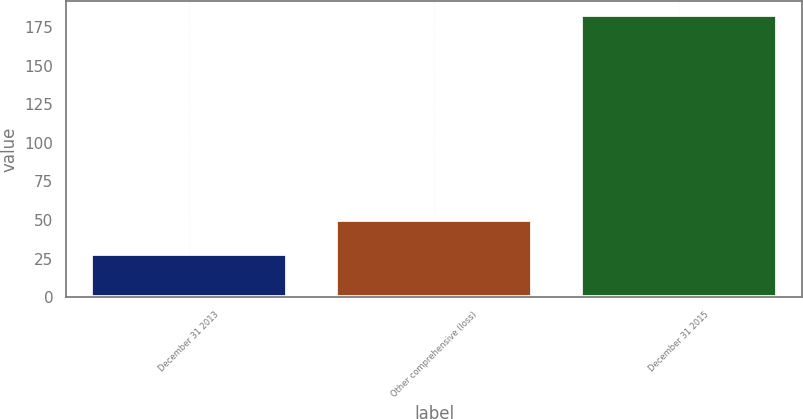Convert chart. <chart><loc_0><loc_0><loc_500><loc_500><bar_chart><fcel>December 31 2013<fcel>Other comprehensive (loss)<fcel>December 31 2015<nl><fcel>27.6<fcel>49.8<fcel>182.6<nl></chart> 